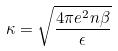<formula> <loc_0><loc_0><loc_500><loc_500>\kappa = \sqrt { \frac { 4 \pi e ^ { 2 } n \beta } { \epsilon } }</formula> 